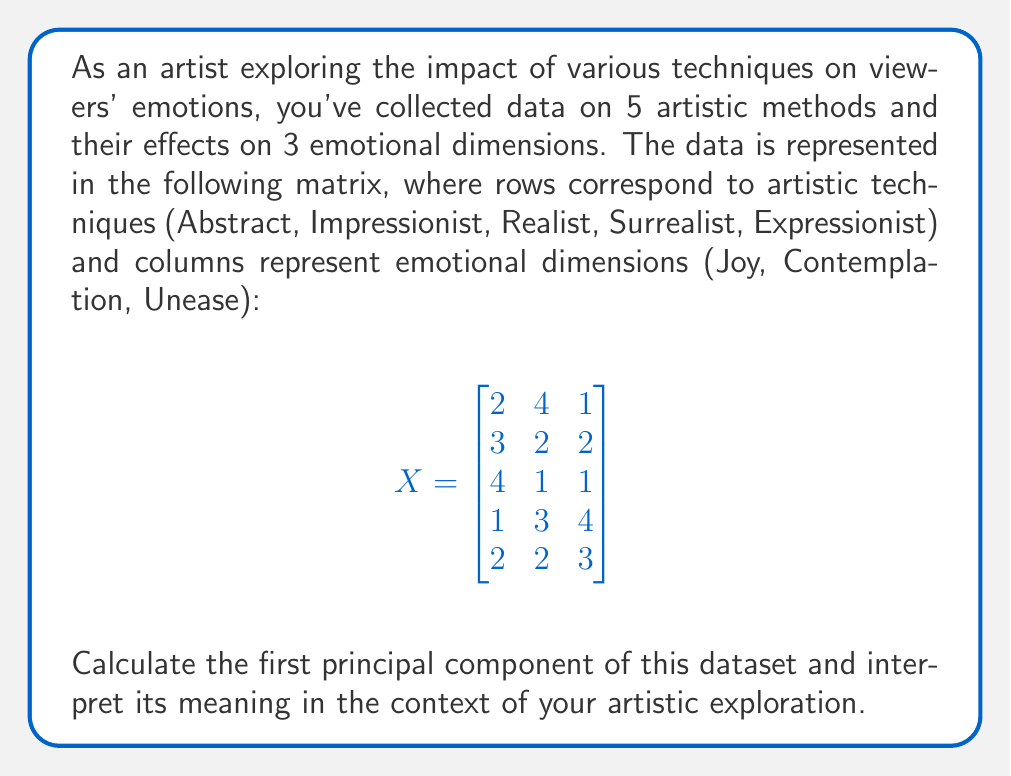Solve this math problem. To find the first principal component, we'll follow these steps:

1) Center the data by subtracting the mean of each column:

Mean of each column:
$$\bar{X} = [2.4, 2.4, 2.2]$$

Centered data matrix:
$$
X_c = \begin{bmatrix}
-0.4 & 1.6 & -1.2 \\
0.6 & -0.4 & -0.2 \\
1.6 & -1.4 & -1.2 \\
-1.4 & 0.6 & 1.8 \\
-0.4 & -0.4 & 0.8
\end{bmatrix}
$$

2) Compute the covariance matrix:
$$
S = \frac{1}{n-1}X_c^T X_c = \begin{bmatrix}
1.3 & -1.15 & -1.05 \\
-1.15 & 1.3 & 0.25 \\
-1.05 & 0.25 & 1.7
\end{bmatrix}
$$

3) Find eigenvalues and eigenvectors of S:

Using a computer algebra system, we get:

Eigenvalues: $\lambda_1 = 3.0724, \lambda_2 = 0.8776, \lambda_3 = 0.3500$

Corresponding eigenvectors:
$$
v_1 = [-0.6124, 0.4834, 0.6246]^T
$$

4) The first principal component is the eigenvector corresponding to the largest eigenvalue:
$$
PC_1 = [-0.6124, 0.4834, 0.6246]^T
$$

Interpretation: This principal component represents a contrast between Joy (-0.6124) and the combination of Contemplation (0.4834) and Unease (0.6246). It suggests that in your artistic techniques, there's a tendency for Joy to be inversely related to Contemplation and Unease. Techniques that evoke more Joy tend to evoke less Contemplation and Unease, and vice versa.
Answer: $PC_1 = [-0.6124, 0.4834, 0.6246]^T$ 